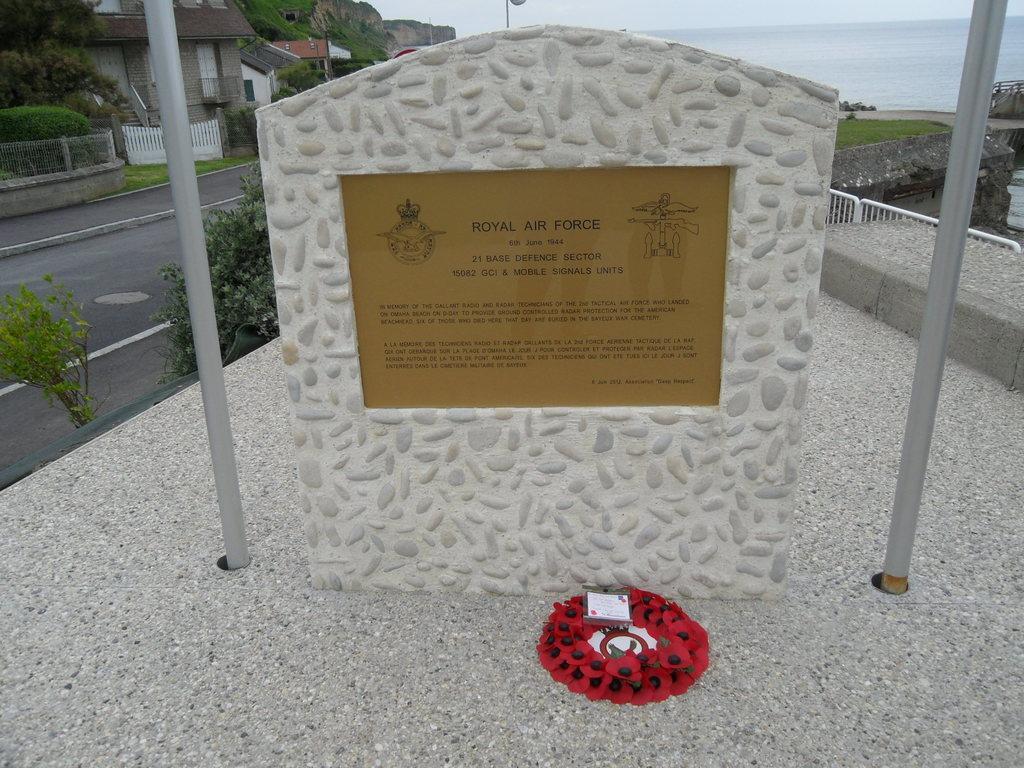Can you describe this image briefly? In the front of the image there are poles, memorial stone, board and an object. Something is written on the board. In the background of the image there are houses, trees, plants, railings, road, grass, sky and objects.   